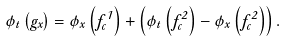<formula> <loc_0><loc_0><loc_500><loc_500>\phi _ { t } \left ( g _ { x } \right ) = \phi _ { x } \left ( f ^ { 1 } _ { c } \right ) + \left ( \phi _ { t } \left ( f ^ { 2 } _ { c } \right ) - \phi _ { x } \left ( f ^ { 2 } _ { c } \right ) \right ) .</formula> 